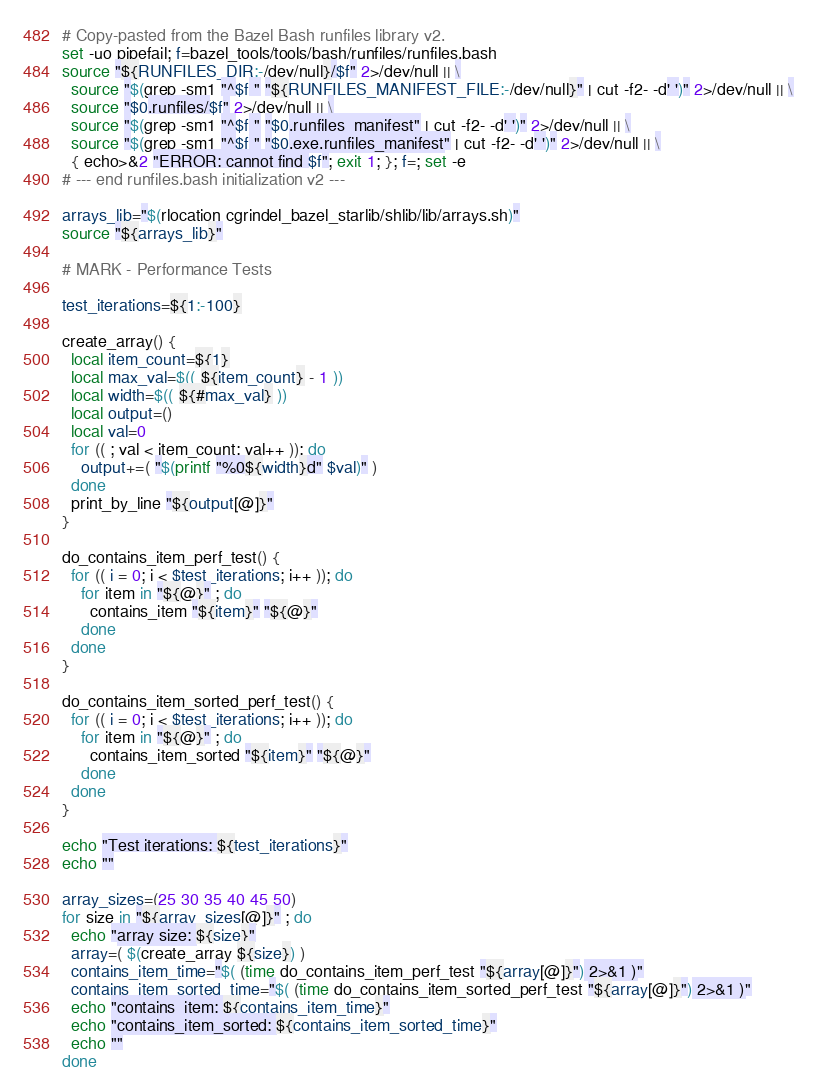Convert code to text. <code><loc_0><loc_0><loc_500><loc_500><_Bash_># Copy-pasted from the Bazel Bash runfiles library v2.
set -uo pipefail; f=bazel_tools/tools/bash/runfiles/runfiles.bash
source "${RUNFILES_DIR:-/dev/null}/$f" 2>/dev/null || \
  source "$(grep -sm1 "^$f " "${RUNFILES_MANIFEST_FILE:-/dev/null}" | cut -f2- -d' ')" 2>/dev/null || \
  source "$0.runfiles/$f" 2>/dev/null || \
  source "$(grep -sm1 "^$f " "$0.runfiles_manifest" | cut -f2- -d' ')" 2>/dev/null || \
  source "$(grep -sm1 "^$f " "$0.exe.runfiles_manifest" | cut -f2- -d' ')" 2>/dev/null || \
  { echo>&2 "ERROR: cannot find $f"; exit 1; }; f=; set -e
# --- end runfiles.bash initialization v2 ---

arrays_lib="$(rlocation cgrindel_bazel_starlib/shlib/lib/arrays.sh)"
source "${arrays_lib}"

# MARK - Performance Tests

test_iterations=${1:-100}

create_array() {
  local item_count=${1}
  local max_val=$(( ${item_count} - 1 ))
  local width=$(( ${#max_val} ))
  local output=()
  local val=0
  for (( ; val < item_count; val++ )); do
    output+=( "$(printf "%0${width}d" $val)" )
  done
  print_by_line "${output[@]}"
}

do_contains_item_perf_test() {
  for (( i = 0; i < $test_iterations; i++ )); do
    for item in "${@}" ; do
      contains_item "${item}" "${@}"
    done
  done
}

do_contains_item_sorted_perf_test() {
  for (( i = 0; i < $test_iterations; i++ )); do
    for item in "${@}" ; do
      contains_item_sorted "${item}" "${@}"
    done
  done
}

echo "Test iterations: ${test_iterations}"
echo ""

array_sizes=(25 30 35 40 45 50)
for size in "${array_sizes[@]}" ; do
  echo "array size: ${size}" 
  array=( $(create_array ${size}) )
  contains_item_time="$( (time do_contains_item_perf_test "${array[@]}") 2>&1 )"
  contains_item_sorted_time="$( (time do_contains_item_sorted_perf_test "${array[@]}") 2>&1 )"
  echo "contains_item: ${contains_item_time}" 
  echo "contains_item_sorted: ${contains_item_sorted_time}" 
  echo ""
done
</code> 